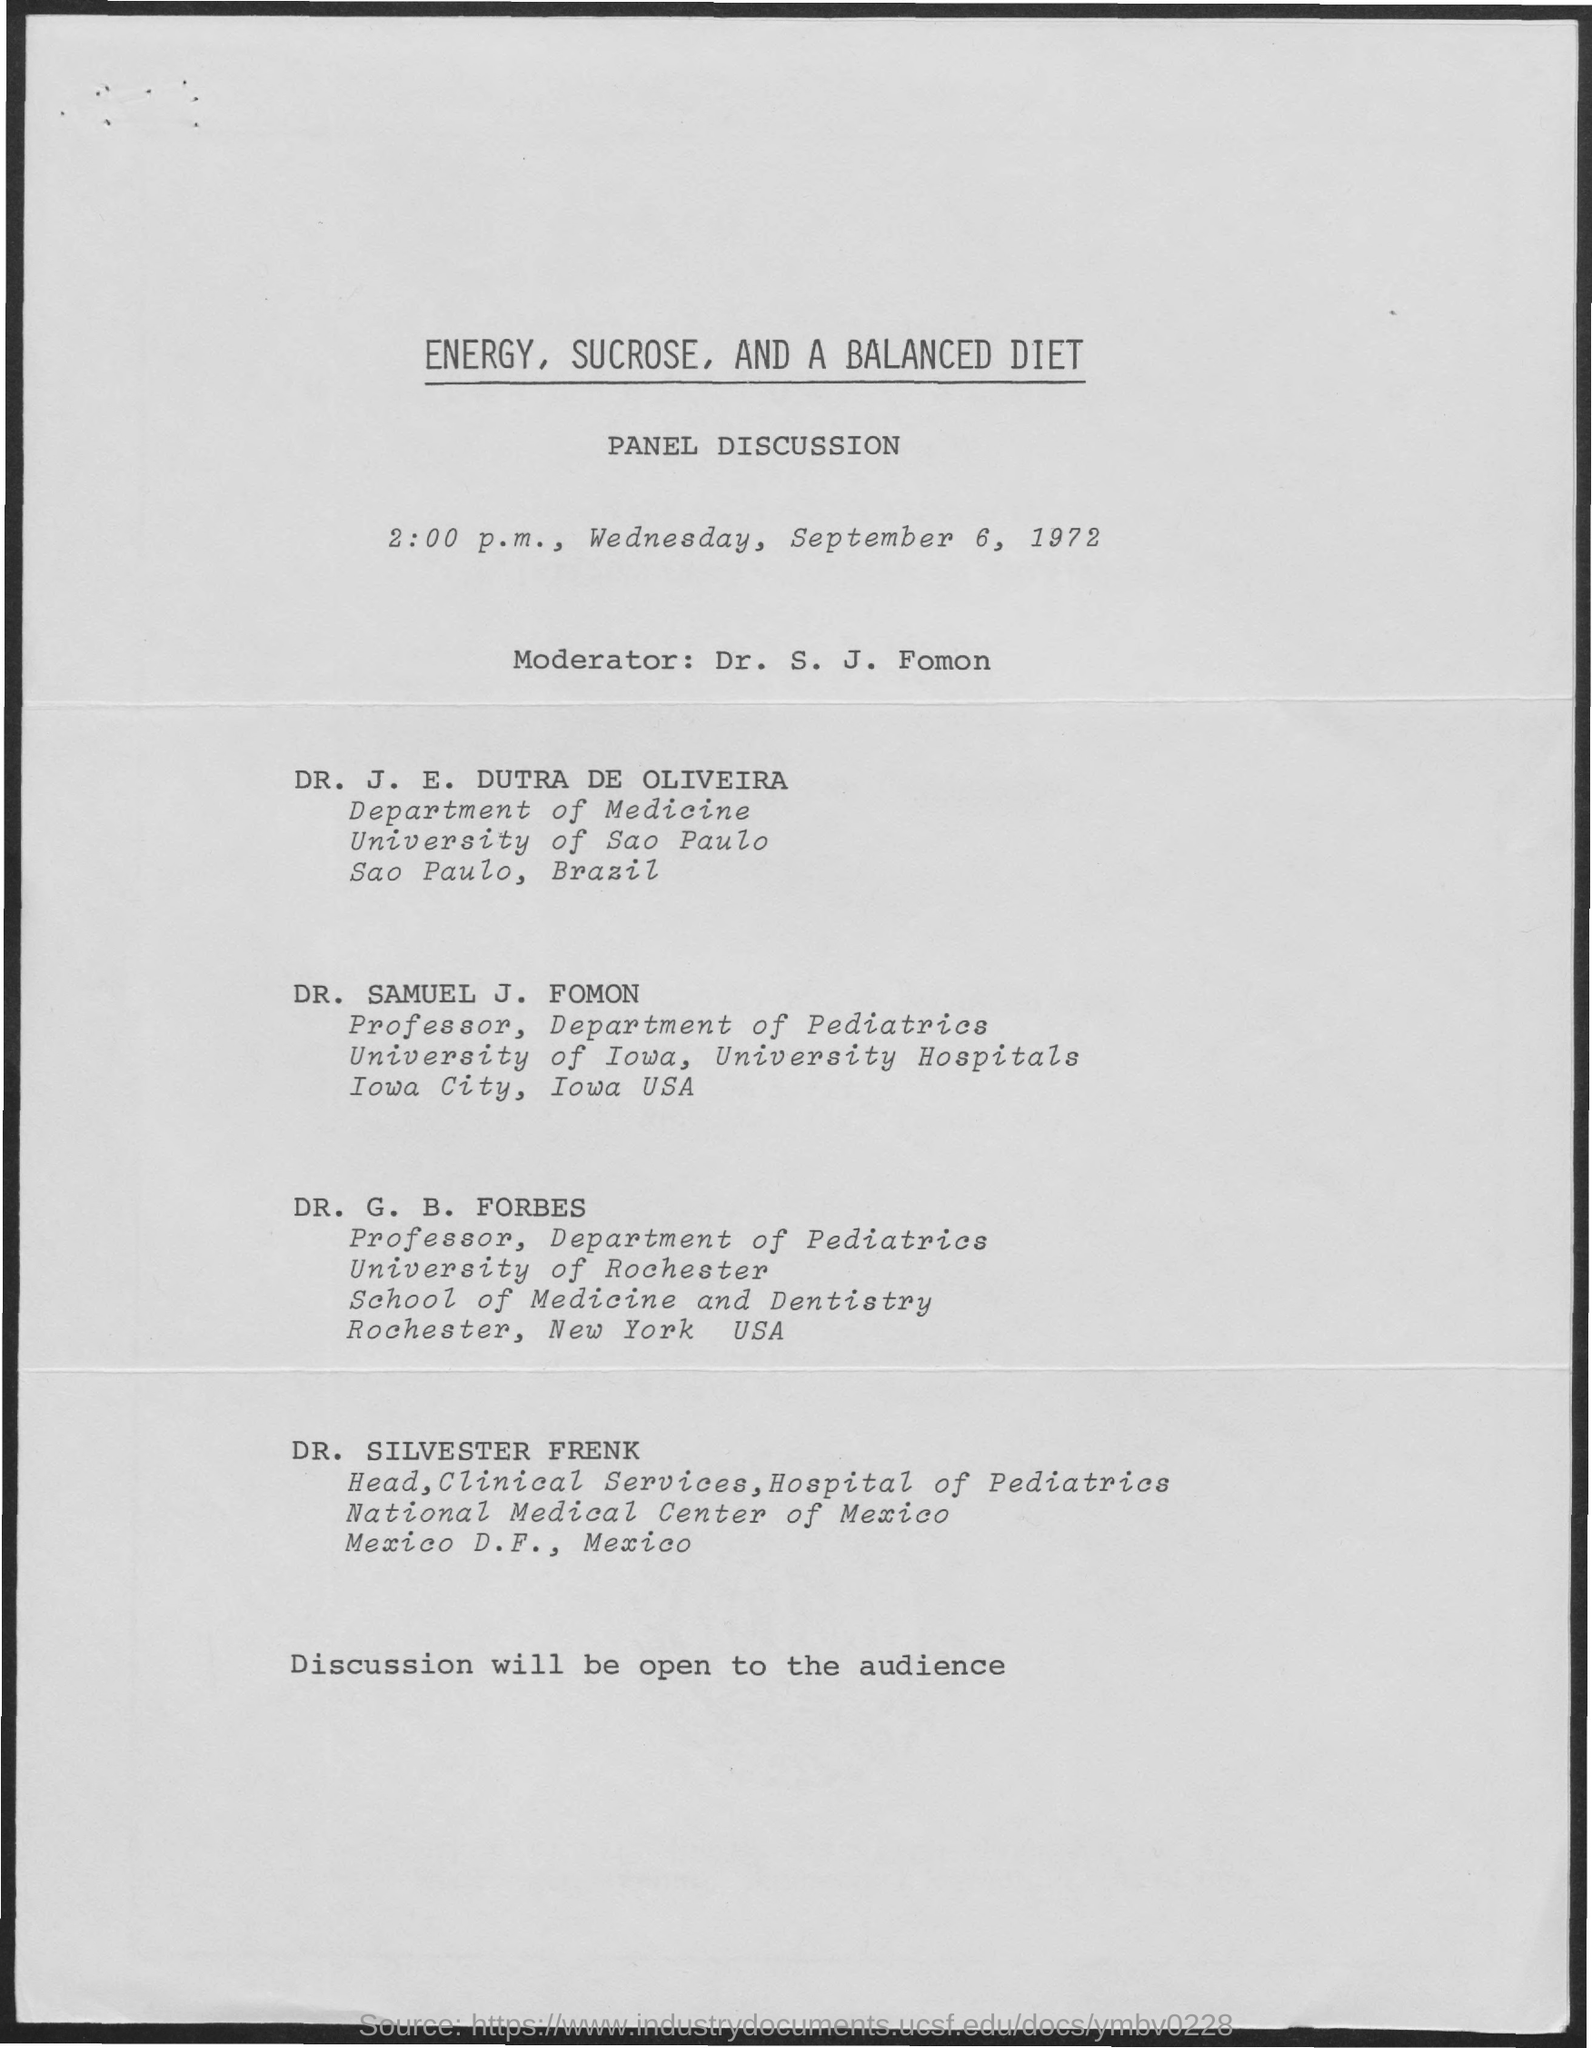What is the first title in the document?
Your answer should be very brief. Energy, Sucrose, and A Balanced Diet. Who is the moderator?
Your answer should be very brief. Dr. s. j. fomon. 